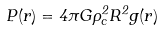Convert formula to latex. <formula><loc_0><loc_0><loc_500><loc_500>P ( r ) = 4 \pi G \rho _ { c } ^ { 2 } R ^ { 2 } g ( r )</formula> 